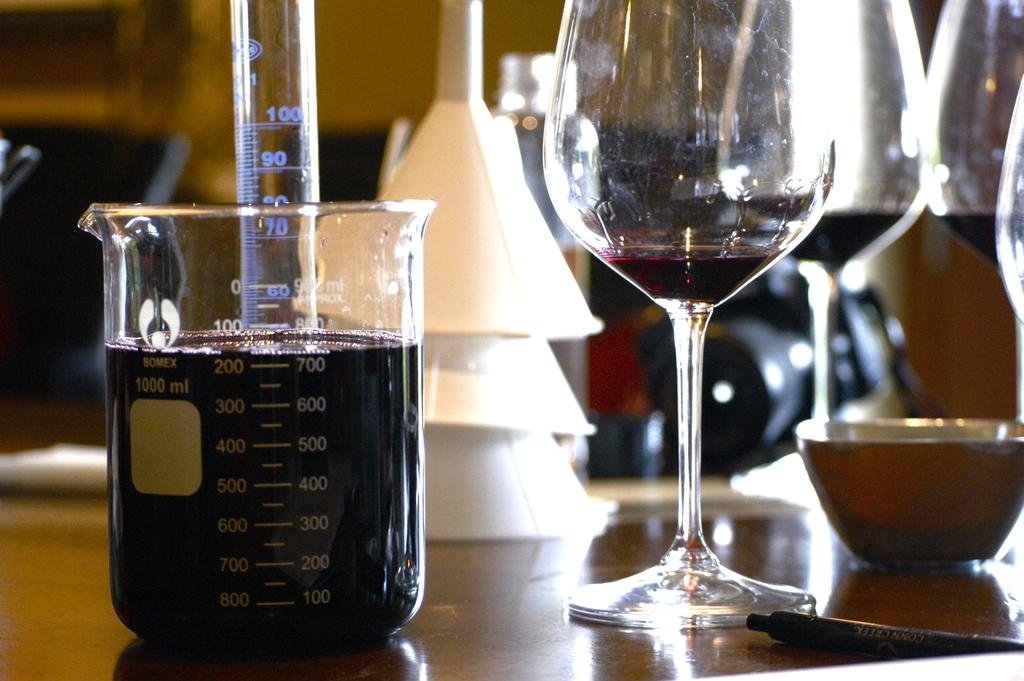<image>
Relay a brief, clear account of the picture shown. The liquid in the beaker is past the 700 ml mark on the right. 